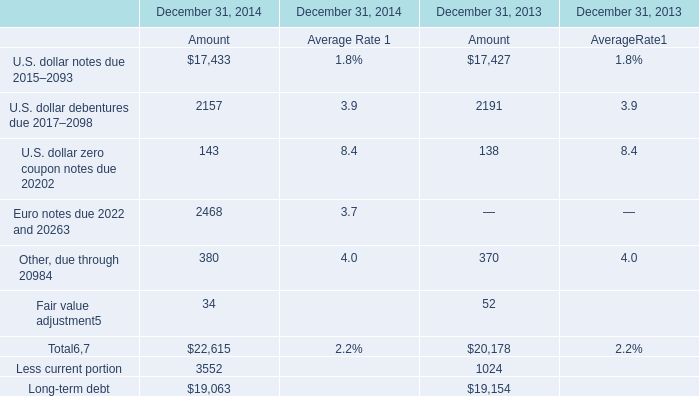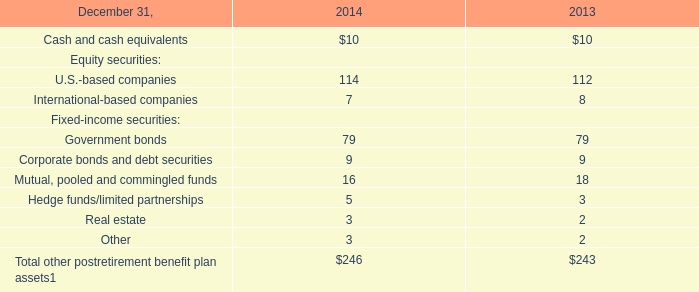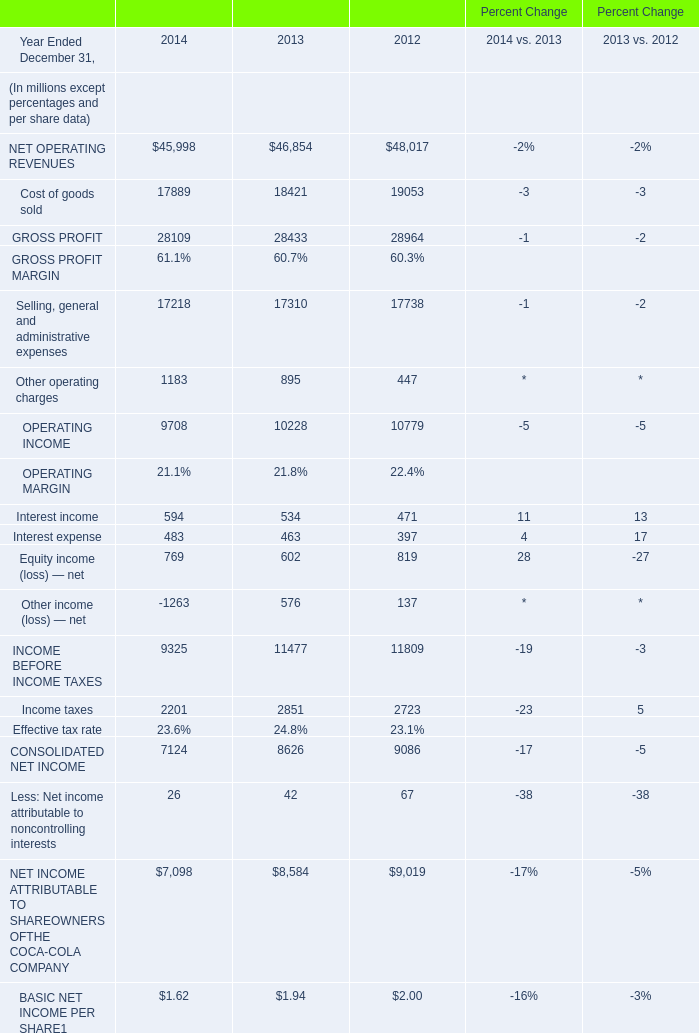What's the average of the Interest income in the years where Government bonds for Fixed-income securities is positive? (in million) 
Computations: ((594 + 534) / 2)
Answer: 564.0. 